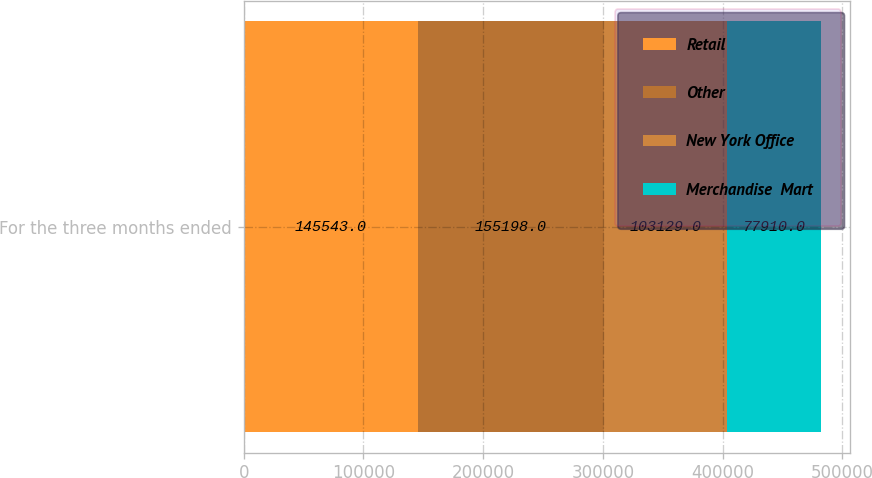Convert chart to OTSL. <chart><loc_0><loc_0><loc_500><loc_500><stacked_bar_chart><ecel><fcel>For the three months ended<nl><fcel>Retail<fcel>145543<nl><fcel>Other<fcel>155198<nl><fcel>New York Office<fcel>103129<nl><fcel>Merchandise  Mart<fcel>77910<nl></chart> 